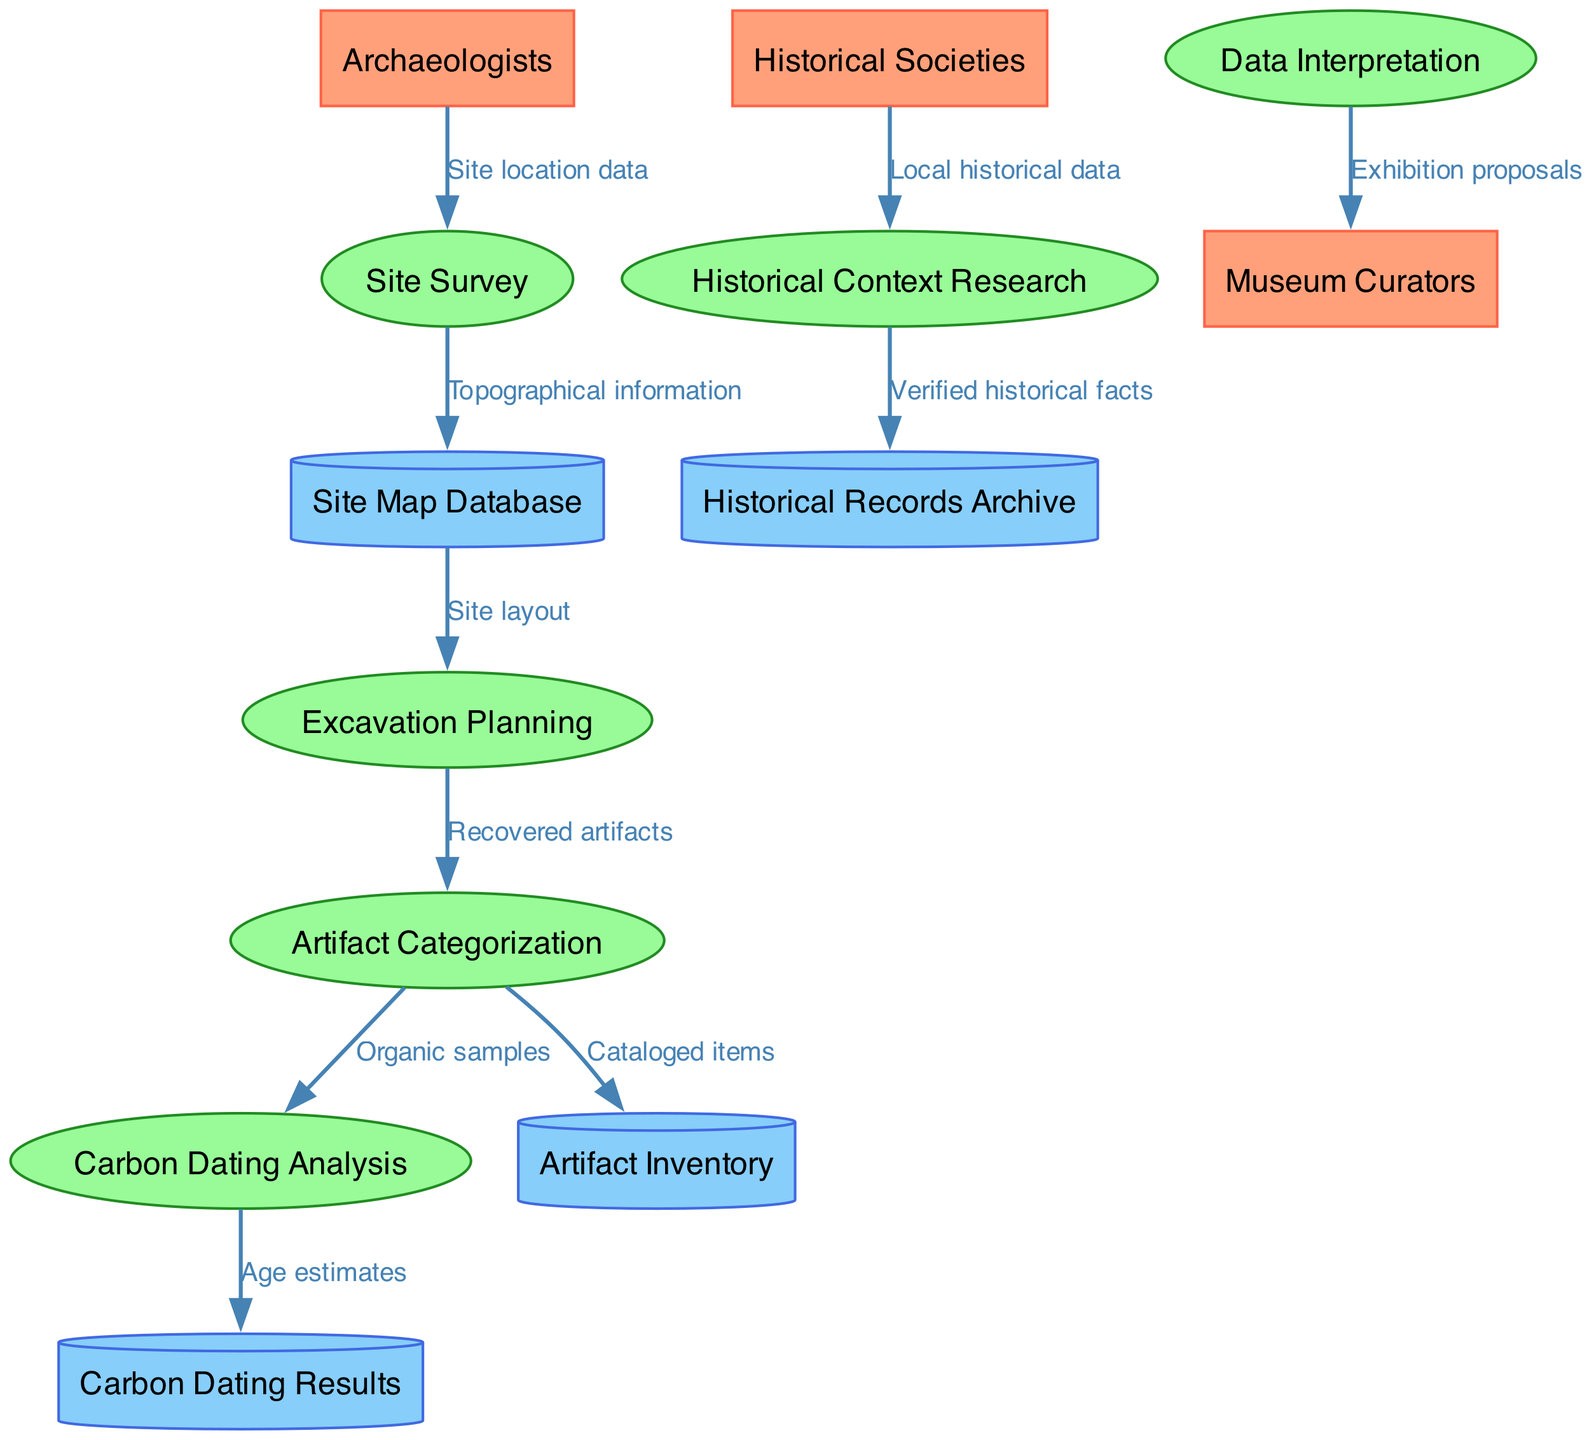What are the external entities in the diagram? The external entities listed in the diagram are "Archaeologists," "Historical Societies," and "Museum Curators." These entities are categorized separately from the processes and data stores, signifying their role as sources or recipients of data in the workflow.
Answer: Archaeologists, Historical Societies, Museum Curators How many processes are depicted in the diagram? The diagram shows six processes: "Site Survey," "Excavation Planning," "Artifact Categorization," "Carbon Dating Analysis," "Historical Context Research," and "Data Interpretation." Counting each of these processes gives a total of six.
Answer: 6 What data flow is between Artifact Categorization and Carbon Dating Analysis? The flow between "Artifact Categorization" and "Carbon Dating Analysis" is labeled "Organic samples." This indicates that organic samples are being sent from the process of categorizing artifacts to the carbon dating process.
Answer: Organic samples Which data store receives data from the Site Survey process? The data store that receives information from the "Site Survey" process is the "Site Map Database." This flow indicates that the topographical information is saved in the site map database following the site survey.
Answer: Site Map Database What is the final output directed to Museum Curators from the process of Data Interpretation? The final output directed to "Museum Curators" from the "Data Interpretation" process is "Exhibition proposals." This represents the end result of analyzing and interpreting data, which is intended for exhibition purposes.
Answer: Exhibition proposals How does Historical Societies contribute to Historical Context Research? "Historical Societies" contribute to the "Historical Context Research" process by providing "Local historical data." This flow shows the input of local historical context, necessary for researching the historical significance of archaeological findings.
Answer: Local historical data What is the relationship between Excavation Planning and Artifact Categorization? The relationship between "Excavation Planning" and "Artifact Categorization" is that "Recovered artifacts" flow from the excavation planning process to the artifact categorization process. This indicates that artifacts recovered during excavation are subsequently categorized.
Answer: Recovered artifacts How many data stores are there in total? The diagram contains four data stores: "Site Map Database," "Artifact Inventory," "Carbon Dating Results," and "Historical Records Archive." Counting each of these gives a total of four data stores.
Answer: 4 